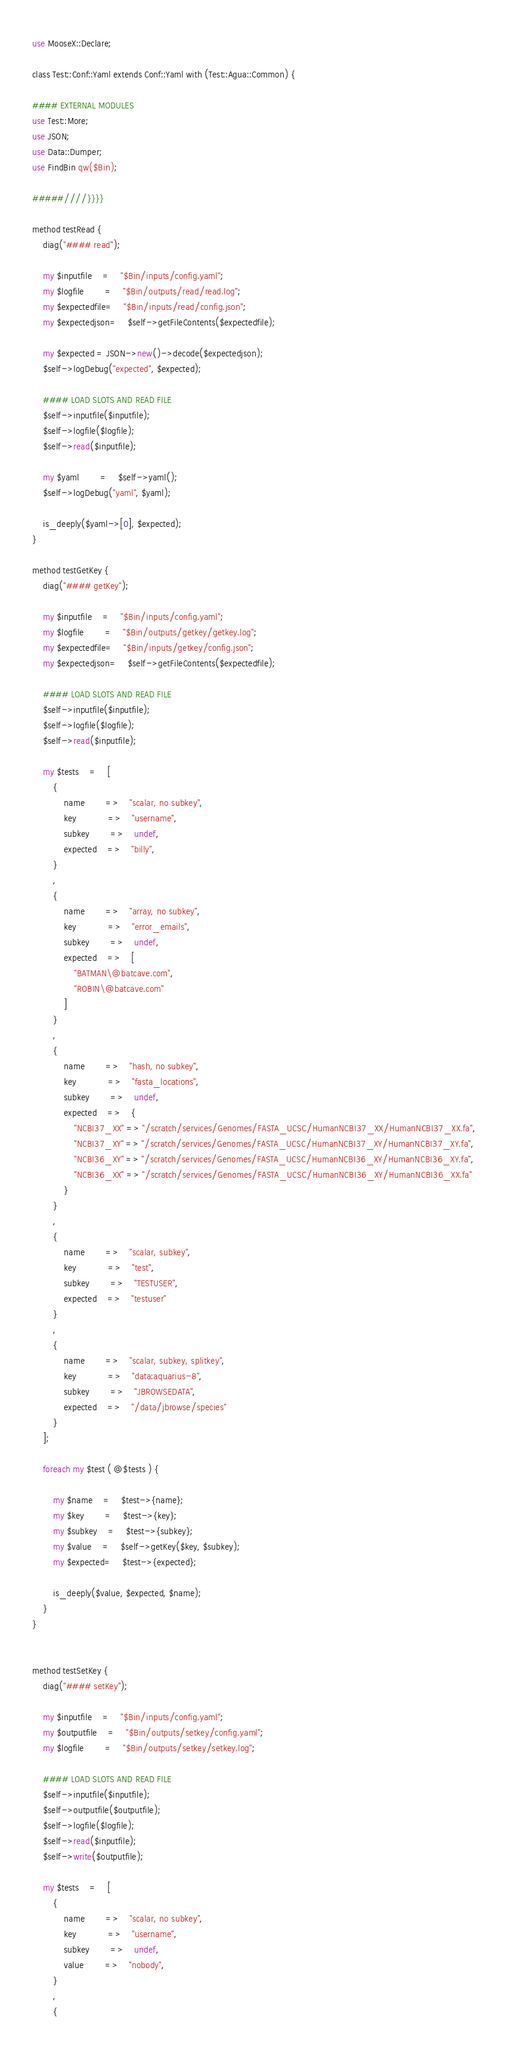Convert code to text. <code><loc_0><loc_0><loc_500><loc_500><_Perl_>use MooseX::Declare;

class Test::Conf::Yaml extends Conf::Yaml with (Test::Agua::Common) {

#### EXTERNAL MODULES
use Test::More;
use JSON;
use Data::Dumper;
use FindBin qw($Bin);

#####////}}}}

method testRead {
	diag("#### read");
	
	my $inputfile	=	"$Bin/inputs/config.yaml";
	my $logfile		=	"$Bin/outputs/read/read.log";	
	my $expectedfile=	"$Bin/inputs/read/config.json";
	my $expectedjson=	$self->getFileContents($expectedfile);

	my $expected = JSON->new()->decode($expectedjson);
	$self->logDebug("expected", $expected);
	
	#### LOAD SLOTS AND READ FILE	
	$self->inputfile($inputfile);
	$self->logfile($logfile);
	$self->read($inputfile);

	my $yaml 		= 	$self->yaml();
	$self->logDebug("yaml", $yaml);
	
	is_deeply($yaml->[0], $expected);
}

method testGetKey {
	diag("#### getKey");
	
	my $inputfile	=	"$Bin/inputs/config.yaml";
	my $logfile		=	"$Bin/outputs/getkey/getkey.log";	
	my $expectedfile=	"$Bin/inputs/getkey/config.json";
	my $expectedjson=	$self->getFileContents($expectedfile);

	#### LOAD SLOTS AND READ FILE	
	$self->inputfile($inputfile);
	$self->logfile($logfile);
	$self->read($inputfile);

	my $tests	=	[
		{
			name		=>	"scalar, no subkey",
			key			=>	"username",
			subkey		=>	undef,
			expected	=>	"billy",
		}
		,
		{
			name		=>	"array, no subkey",
			key			=>	"error_emails",
			subkey		=>	undef,
			expected	=>	[
				"BATMAN\@batcave.com",
				"ROBIN\@batcave.com"
			]
		}
		,
		{
			name		=>	"hash, no subkey",
			key			=>	"fasta_locations",
			subkey		=>	undef,
			expected	=>	{
				"NCBI37_XX" => "/scratch/services/Genomes/FASTA_UCSC/HumanNCBI37_XX/HumanNCBI37_XX.fa",
				"NCBI37_XY" => "/scratch/services/Genomes/FASTA_UCSC/HumanNCBI37_XY/HumanNCBI37_XY.fa",
				"NCBI36_XY" => "/scratch/services/Genomes/FASTA_UCSC/HumanNCBI36_XY/HumanNCBI36_XY.fa",
				"NCBI36_XX" => "/scratch/services/Genomes/FASTA_UCSC/HumanNCBI36_XY/HumanNCBI36_XX.fa"
			}
		}
		,
		{
			name		=>	"scalar, subkey",
			key			=>	"test",
			subkey		=>	"TESTUSER",
			expected	=>	"testuser"
		}
		,
		{
			name		=>	"scalar, subkey, splitkey",
			key			=>	"data:aquarius-8",
			subkey		=>	"JBROWSEDATA",
			expected	=>	"/data/jbrowse/species"
		}
	];

	foreach my $test ( @$tests ) {

		my $name	=	$test->{name};
		my $key		=	$test->{key};
		my $subkey	=	$test->{subkey};
		my $value	=	$self->getKey($key, $subkey);
		my $expected=	$test->{expected};
		
		is_deeply($value, $expected, $name);
	}
}


method testSetKey {
	diag("#### setKey");
	
	my $inputfile	=	"$Bin/inputs/config.yaml";
	my $outputfile	=	"$Bin/outputs/setkey/config.yaml";
	my $logfile		=	"$Bin/outputs/setkey/setkey.log";	

	#### LOAD SLOTS AND READ FILE	
	$self->inputfile($inputfile);
	$self->outputfile($outputfile);
	$self->logfile($logfile);
	$self->read($inputfile);
	$self->write($outputfile);

	my $tests	=	[
		{
			name		=>	"scalar, no subkey",
			key			=>	"username",
			subkey		=>	undef,
			value		=>	"nobody",
		}
		,
		{</code> 